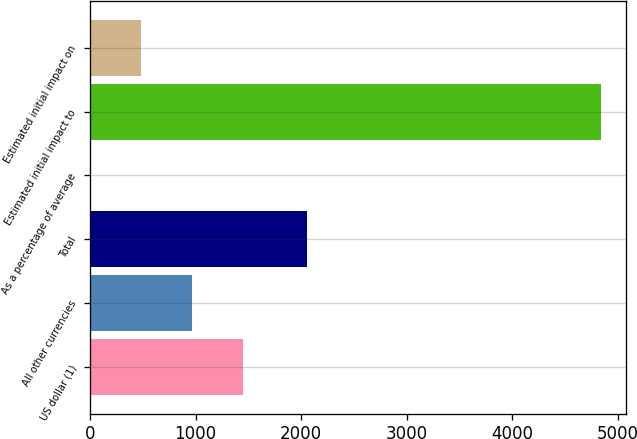<chart> <loc_0><loc_0><loc_500><loc_500><bar_chart><fcel>US dollar (1)<fcel>All other currencies<fcel>Total<fcel>As a percentage of average<fcel>Estimated initial impact to<fcel>Estimated initial impact on<nl><fcel>1451.2<fcel>967.51<fcel>2054<fcel>0.13<fcel>4837<fcel>483.82<nl></chart> 